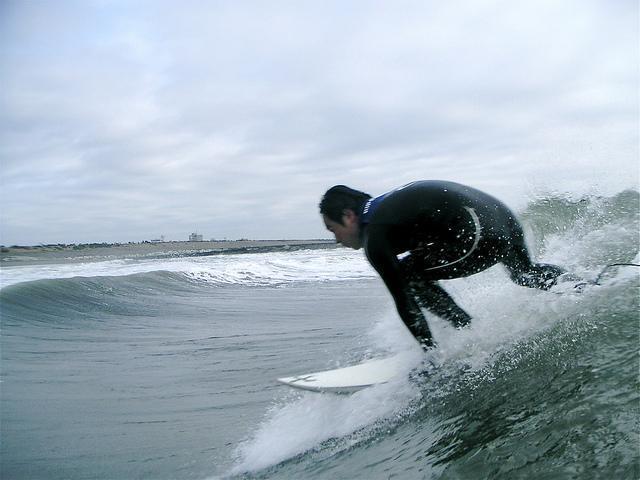How many people are there?
Give a very brief answer. 1. 